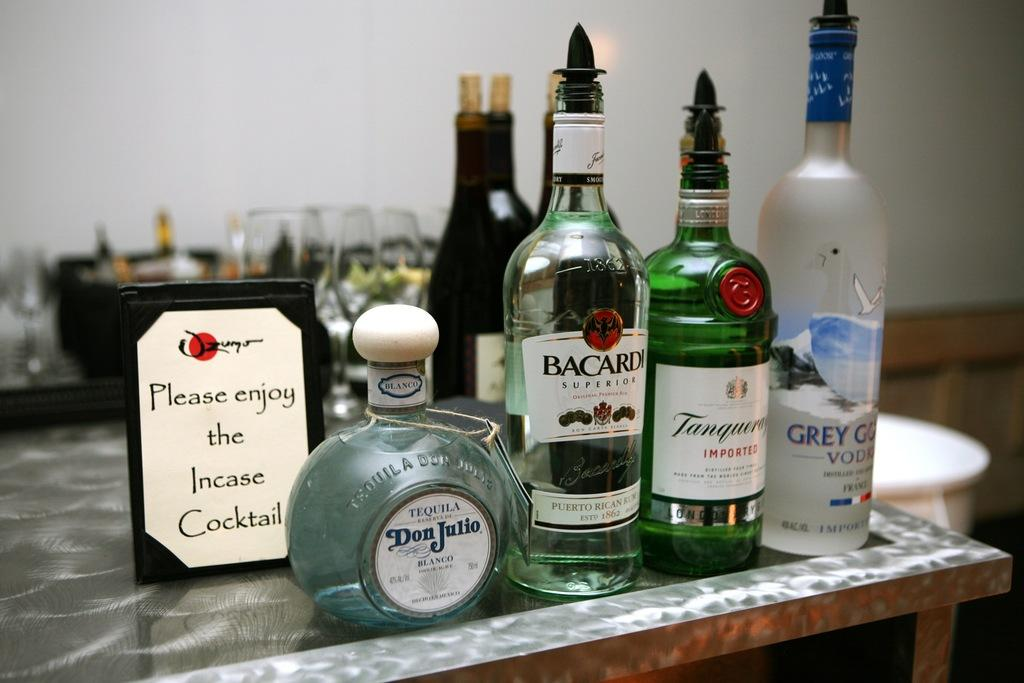Provide a one-sentence caption for the provided image. A bottle of Bacardi on a counter with other bottles of alcohol. 